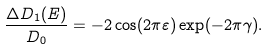Convert formula to latex. <formula><loc_0><loc_0><loc_500><loc_500>\frac { \Delta D _ { 1 } ( E ) } { D _ { 0 } } = - 2 \cos ( 2 \pi \varepsilon ) \exp ( - 2 \pi \gamma ) .</formula> 